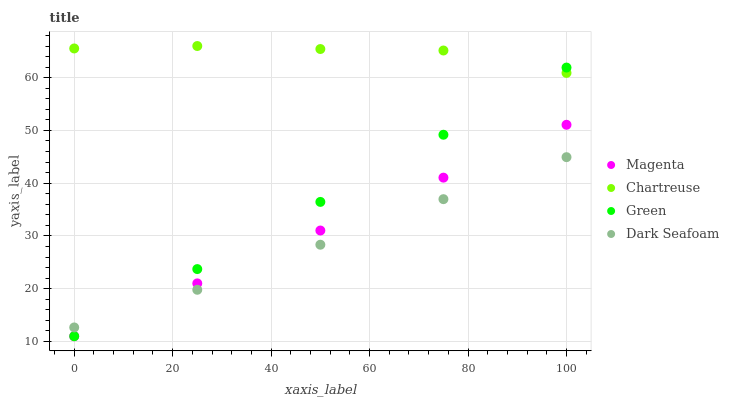Does Dark Seafoam have the minimum area under the curve?
Answer yes or no. Yes. Does Chartreuse have the maximum area under the curve?
Answer yes or no. Yes. Does Green have the minimum area under the curve?
Answer yes or no. No. Does Green have the maximum area under the curve?
Answer yes or no. No. Is Magenta the smoothest?
Answer yes or no. Yes. Is Chartreuse the roughest?
Answer yes or no. Yes. Is Chartreuse the smoothest?
Answer yes or no. No. Is Green the roughest?
Answer yes or no. No. Does Magenta have the lowest value?
Answer yes or no. Yes. Does Chartreuse have the lowest value?
Answer yes or no. No. Does Chartreuse have the highest value?
Answer yes or no. Yes. Does Green have the highest value?
Answer yes or no. No. Is Dark Seafoam less than Chartreuse?
Answer yes or no. Yes. Is Chartreuse greater than Magenta?
Answer yes or no. Yes. Does Magenta intersect Dark Seafoam?
Answer yes or no. Yes. Is Magenta less than Dark Seafoam?
Answer yes or no. No. Is Magenta greater than Dark Seafoam?
Answer yes or no. No. Does Dark Seafoam intersect Chartreuse?
Answer yes or no. No. 